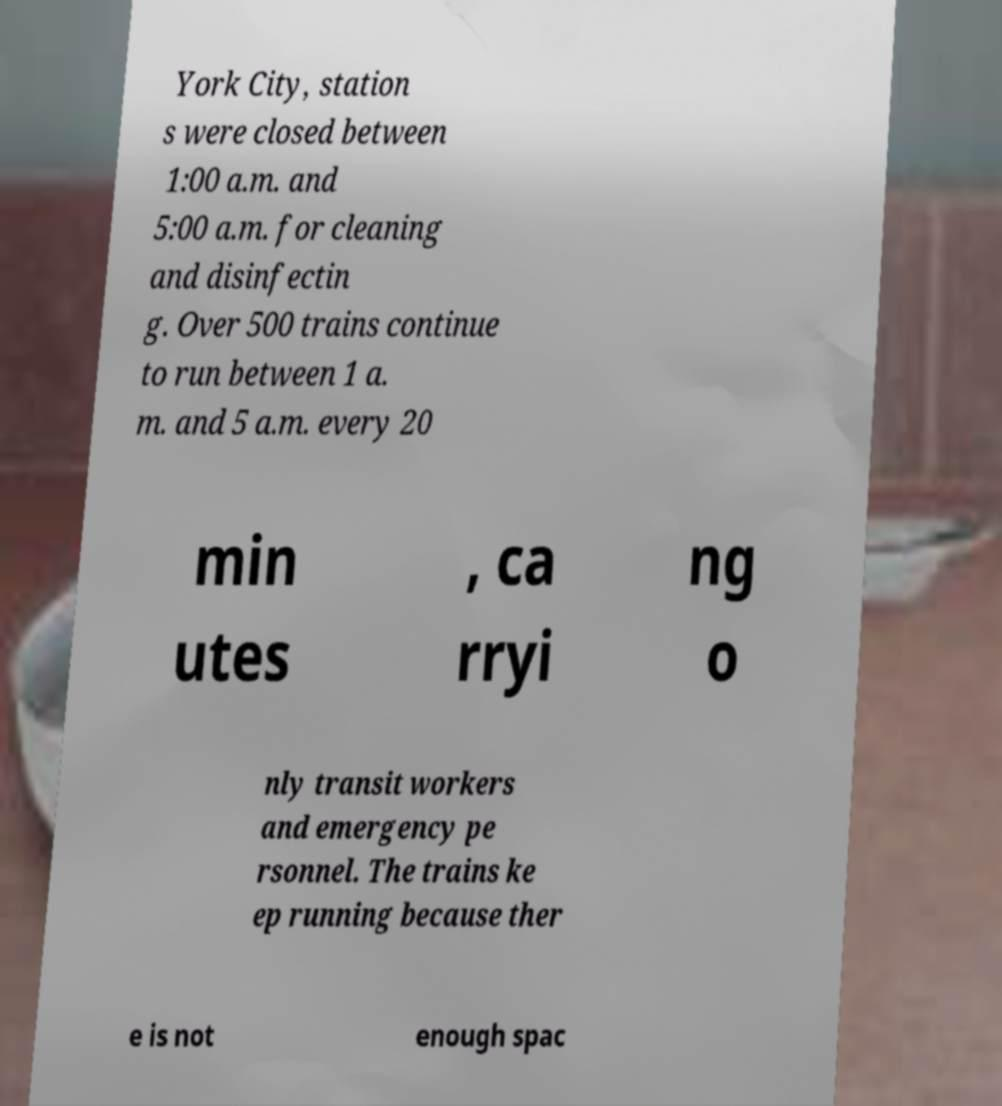Could you extract and type out the text from this image? York City, station s were closed between 1:00 a.m. and 5:00 a.m. for cleaning and disinfectin g. Over 500 trains continue to run between 1 a. m. and 5 a.m. every 20 min utes , ca rryi ng o nly transit workers and emergency pe rsonnel. The trains ke ep running because ther e is not enough spac 